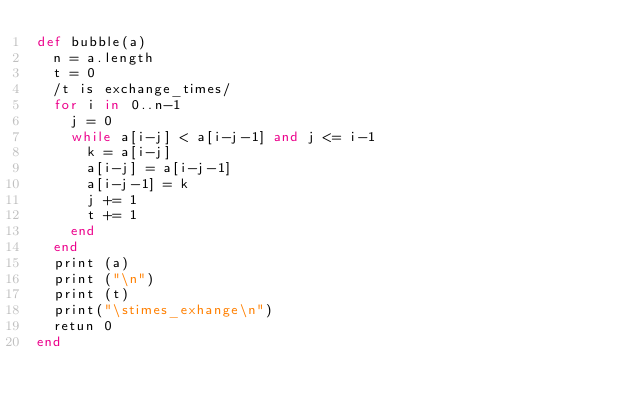<code> <loc_0><loc_0><loc_500><loc_500><_Ruby_>def bubble(a)
  n = a.length
  t = 0           
  /t is exchange_times/
  for i in 0..n-1
    j = 0
    while a[i-j] < a[i-j-1] and j <= i-1
      k = a[i-j]
      a[i-j] = a[i-j-1]
      a[i-j-1] = k
      j += 1
      t += 1
    end
  end
  print (a)
  print ("\n")
  print (t)
  print("\stimes_exhange\n")
  retun 0
end

</code> 